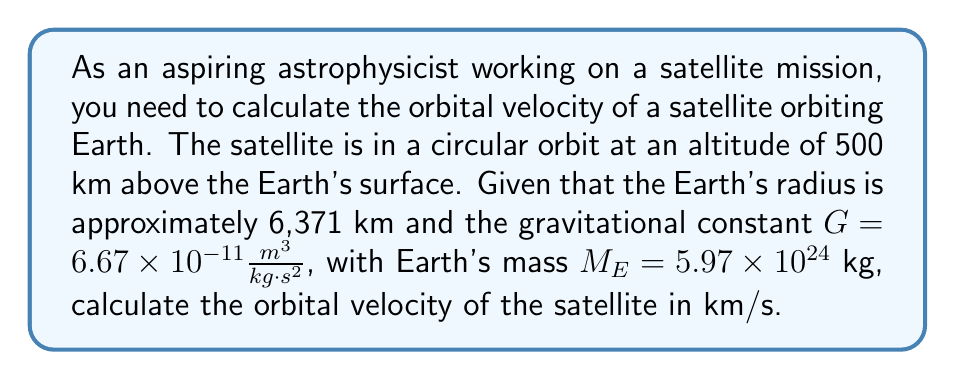Teach me how to tackle this problem. To solve this problem, we'll use the orbital velocity equation for a circular orbit:

$$v = \sqrt{\frac{GM}{r}}$$

Where:
$v$ is the orbital velocity
$G$ is the gravitational constant
$M$ is the mass of the central body (Earth in this case)
$r$ is the distance from the center of the Earth to the satellite

Step 1: Calculate the distance $r$
The distance $r$ is the sum of Earth's radius and the satellite's altitude:
$$r = 6371 \text{ km} + 500 \text{ km} = 6871 \text{ km} = 6.871 \times 10^6 \text{ m}$$

Step 2: Substitute the values into the equation
$$v = \sqrt{\frac{(6.67 \times 10^{-11} \frac{m^3}{kg \cdot s^2})(5.97 \times 10^{24} \text{ kg})}{6.871 \times 10^6 \text{ m}}}$$

Step 3: Simplify and calculate
$$v = \sqrt{5.78 \times 10^7 \frac{m^2}{s^2}}$$
$$v = 7,602 \frac{m}{s}$$

Step 4: Convert to km/s
$$v = 7.602 \frac{km}{s}$$
Answer: The orbital velocity of the satellite is approximately 7.60 km/s. 